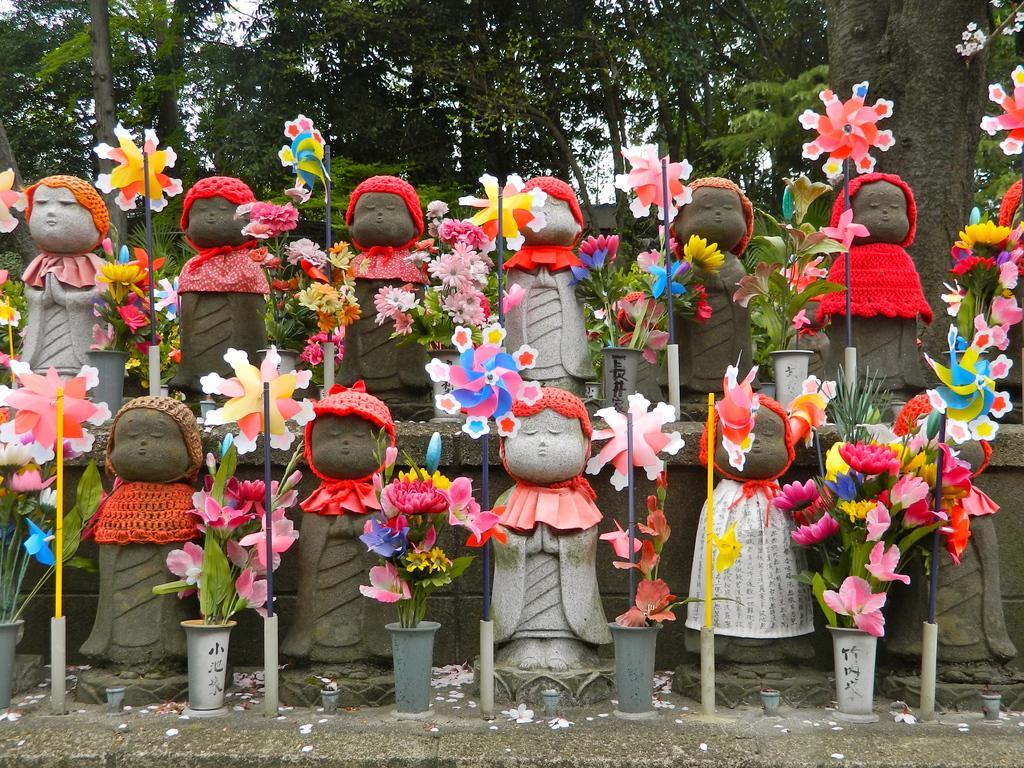What is located in the middle of the image? There are statues in the middle of the image. How are the statues decorated? The statues are decorated with flowers. What can be seen in the background of the image? There are trees in the background of the image. What type of engine is powering the stage in the image? There is no stage or engine present in the image; it features statues decorated with flowers and trees in the background. 